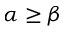<formula> <loc_0><loc_0><loc_500><loc_500>\alpha \geq \beta</formula> 